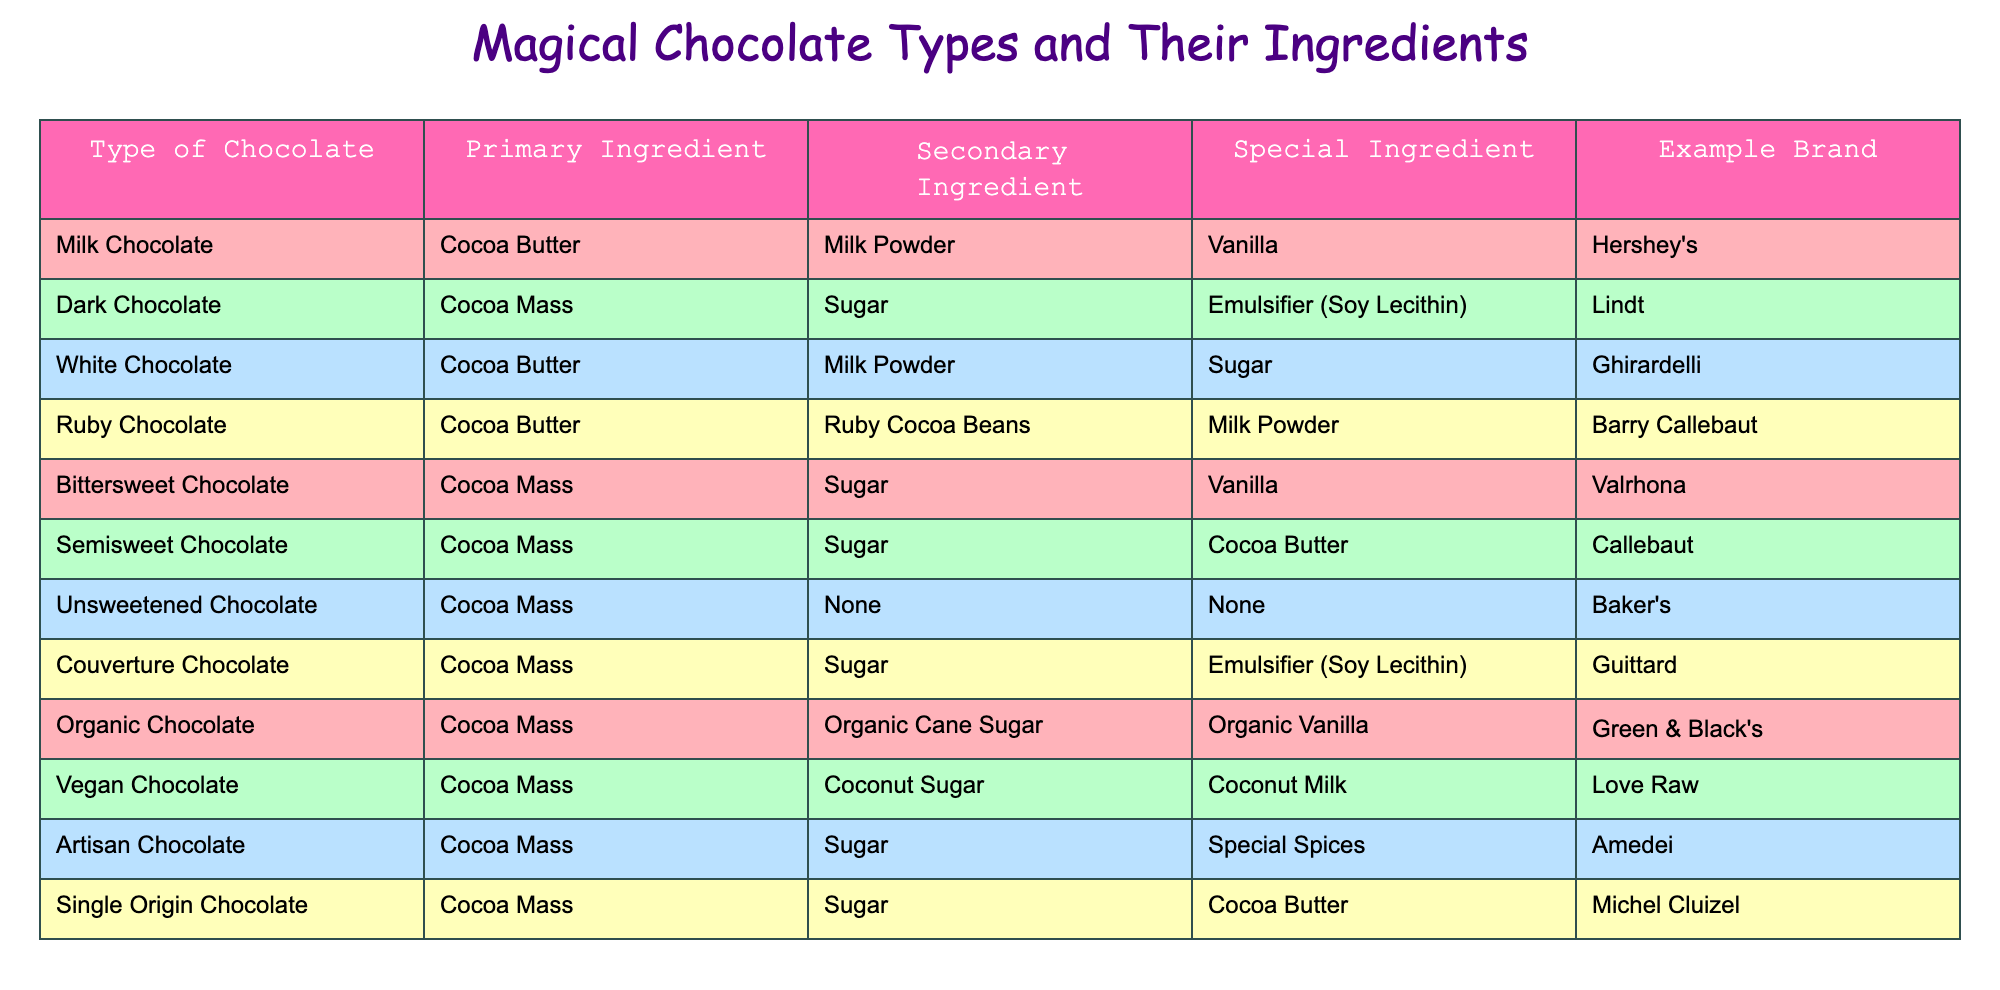What is the primary ingredient in Milk Chocolate? According to the table, the primary ingredient listed for Milk Chocolate is Cocoa Butter.
Answer: Cocoa Butter Which type of chocolate contains Ruby Cocoa Beans as a special ingredient? The table shows that Ruby Chocolate is the type that contains Ruby Cocoa Beans as a special ingredient.
Answer: Ruby Chocolate Is Semisweet Chocolate made without any emulsifiers? The table indicates that Semisweet Chocolate has Cocoa Mass, Sugar, and Cocoa Butter, but does not list any emulsifiers. Therefore, the statement is true.
Answer: Yes How many chocolate types use Cocoa Mass as their primary ingredient? From the table, we can count the types: Dark Chocolate, Bittersweet Chocolate, Semisweet Chocolate, Unsweetened Chocolate, Couverture Chocolate, Organic Chocolate, Vegan Chocolate, Artisan Chocolate, and Single Origin Chocolate. That totals to 9 types.
Answer: 9 Which chocolate has the example brand Ghirardelli? According to the table, the chocolate with the example brand Ghirardelli is White Chocolate.
Answer: White Chocolate Do both Organic Chocolate and Vegan Chocolate contain Sugar as a secondary ingredient? Checking the table, Organic Chocolate has Organic Cane Sugar as a secondary ingredient, while Vegan Chocolate has Coconut Sugar as its secondary ingredient. This means they do not both contain regular Sugar.
Answer: No What is the difference in primary ingredients between Milk Chocolate and Dark Chocolate? Milk Chocolate has Cocoa Butter as its primary ingredient, while Dark Chocolate has Cocoa Mass. Therefore, the difference is that one uses Cocoa Butter and the other uses Cocoa Mass.
Answer: Cocoa Butter and Cocoa Mass Which chocolate type can you find vanilla listed as a special ingredient? Looking at the table, the types of chocolate that list vanilla as a special ingredient are Milk Chocolate and Bittersweet Chocolate.
Answer: Milk Chocolate and Bittersweet Chocolate Which types of chocolate are sweetened with Coconut Sugar? The table specifies that Vegan Chocolate uses Coconut Sugar as its secondary ingredient, indicating it is sweetened with that sugar, and no other types mention it.
Answer: Vegan Chocolate 